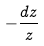<formula> <loc_0><loc_0><loc_500><loc_500>- \frac { d z } { z }</formula> 